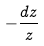<formula> <loc_0><loc_0><loc_500><loc_500>- \frac { d z } { z }</formula> 